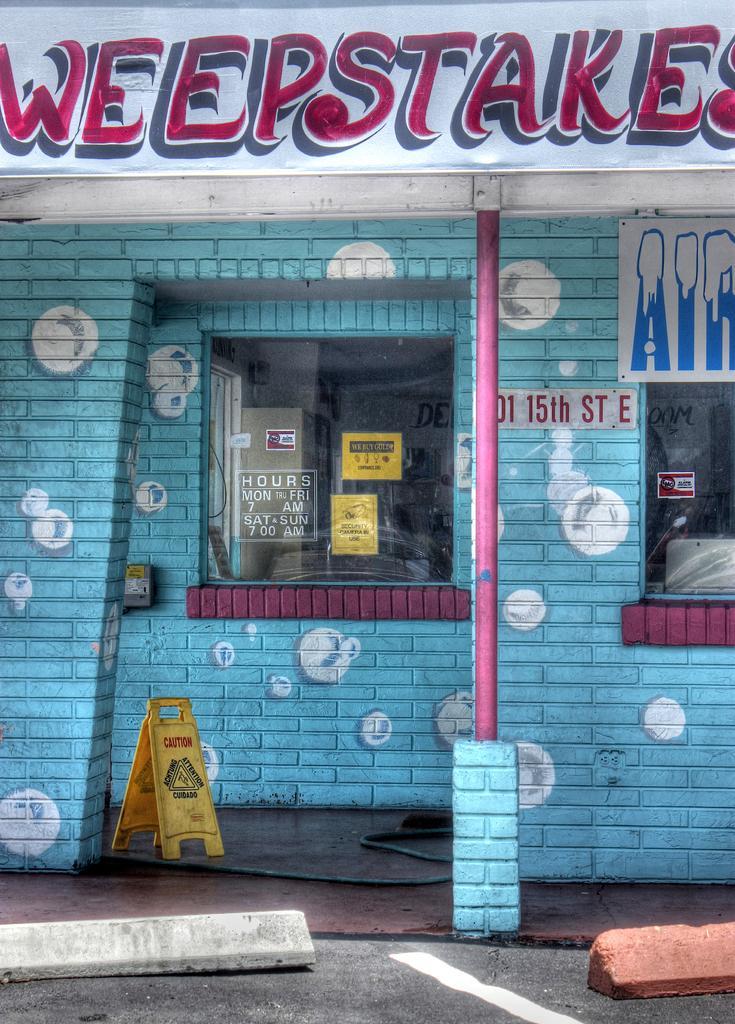Describe this image in one or two sentences. In the image we can see the shop, made up of bricks and these are the glass windows. We can even see the barricade and the poster and on the poster there is a text. 